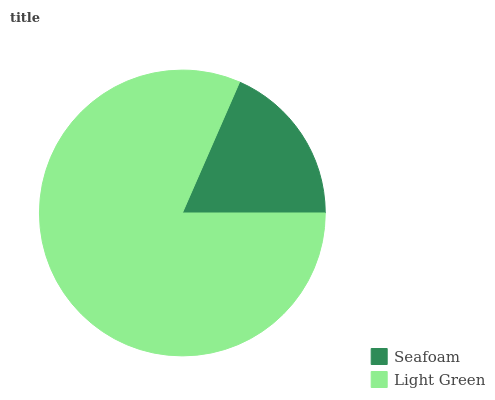Is Seafoam the minimum?
Answer yes or no. Yes. Is Light Green the maximum?
Answer yes or no. Yes. Is Light Green the minimum?
Answer yes or no. No. Is Light Green greater than Seafoam?
Answer yes or no. Yes. Is Seafoam less than Light Green?
Answer yes or no. Yes. Is Seafoam greater than Light Green?
Answer yes or no. No. Is Light Green less than Seafoam?
Answer yes or no. No. Is Light Green the high median?
Answer yes or no. Yes. Is Seafoam the low median?
Answer yes or no. Yes. Is Seafoam the high median?
Answer yes or no. No. Is Light Green the low median?
Answer yes or no. No. 